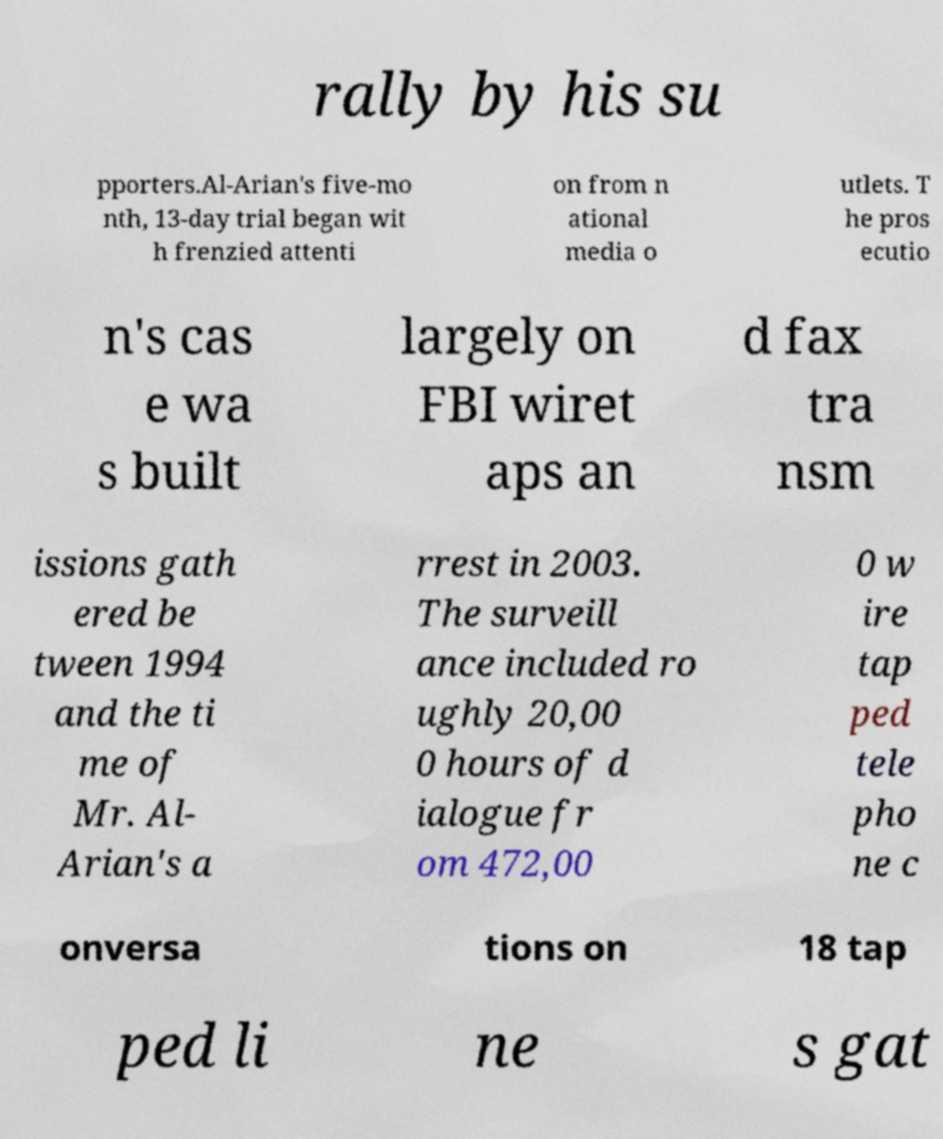Can you accurately transcribe the text from the provided image for me? rally by his su pporters.Al-Arian's five-mo nth, 13-day trial began wit h frenzied attenti on from n ational media o utlets. T he pros ecutio n's cas e wa s built largely on FBI wiret aps an d fax tra nsm issions gath ered be tween 1994 and the ti me of Mr. Al- Arian's a rrest in 2003. The surveill ance included ro ughly 20,00 0 hours of d ialogue fr om 472,00 0 w ire tap ped tele pho ne c onversa tions on 18 tap ped li ne s gat 